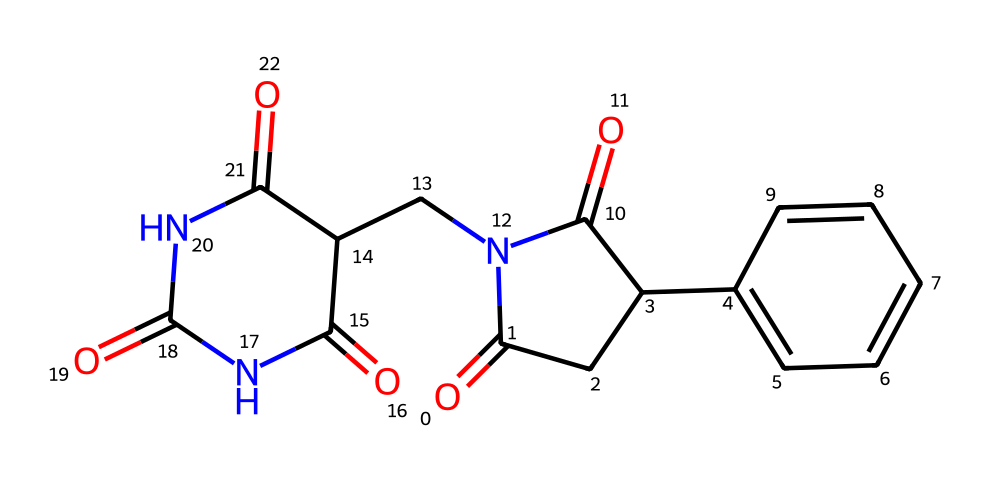What is the molecular formula of thalidomide? By analyzing the SMILES representation, we can count the number of each type of atom present. Thalidomide contains 13 carbon (C), 11 hydrogen (H), 4 oxygen (O), and 2 nitrogen (N) atoms, yielding the molecular formula C13H10N2O4.
Answer: C13H10N2O4 How many chiral centers are present in thalidomide? A chiral center is generally a carbon atom that is bonded to four different groups. In thalidomide's structure, there are two carbon atoms that fit this definition, indicating the presence of two chiral centers.
Answer: 2 What functional groups are present in thalidomide? Examining the SMILES shows there are carbonyl (C=O), amide (N-C=O), and aromatic (C=C) functional groups. All these groups provide distinct reactivity and properties to the molecule.
Answer: carbonyl, amide, aromatic What is the significance of thalidomide's enantiomers? Thalidomide has two enantiomers; one is effective for treating certain conditions, while the other is associated with teratogenic effects. This highlights the importance of chirality in drug design and safety.
Answer: therapeutic and teratogenic effects How many rings are present in the chemical structure of thalidomide? The SMILES representation indicates there are two distinct cyclic structures in thalidomide, confirmed by looking at the fused ring systems in the chemical structure.
Answer: 2 What type of isomerism is illustrated by thalidomide? Thalidomide exhibits optical isomerism because it has chiral centers, leading to the presence of enantiomers. This can significantly impact the biological activity of the compound.
Answer: optical isomerism 